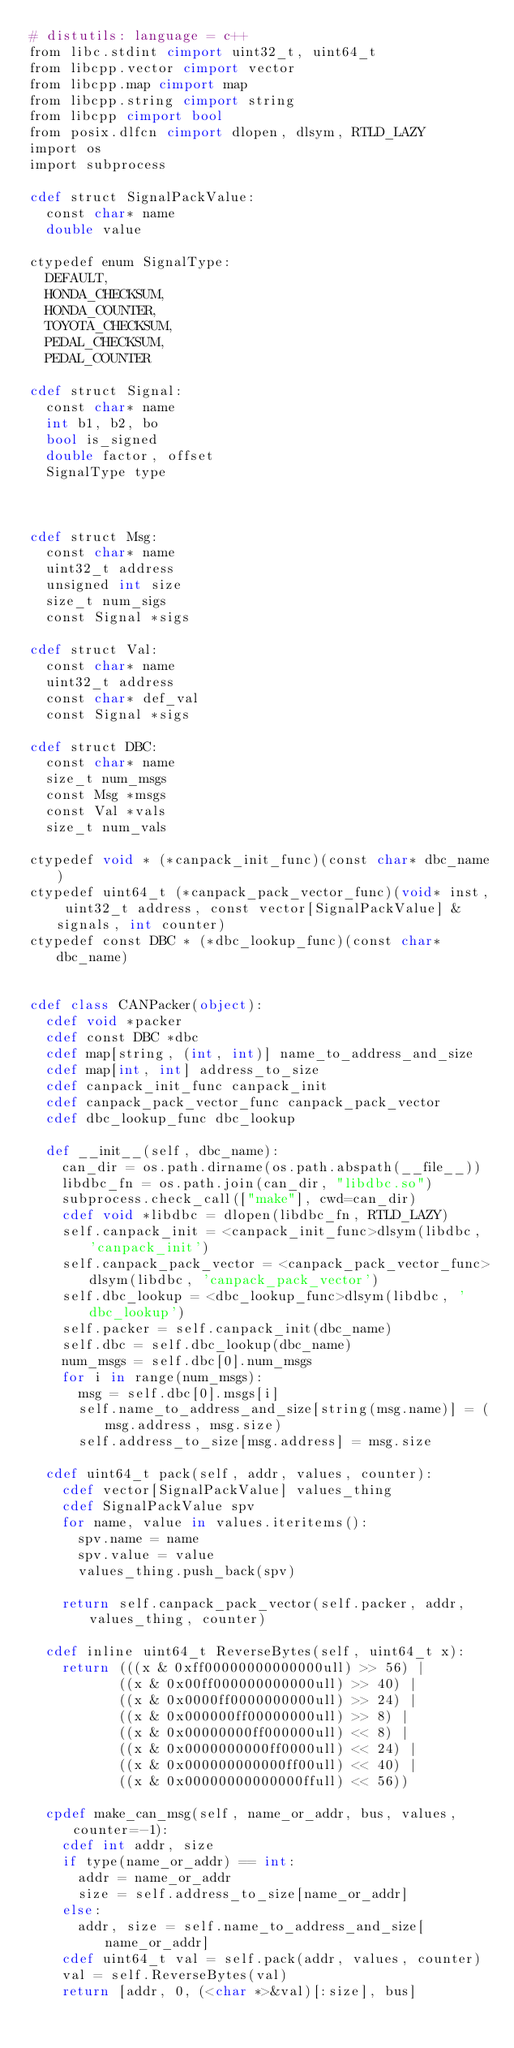<code> <loc_0><loc_0><loc_500><loc_500><_Cython_># distutils: language = c++
from libc.stdint cimport uint32_t, uint64_t
from libcpp.vector cimport vector
from libcpp.map cimport map
from libcpp.string cimport string
from libcpp cimport bool
from posix.dlfcn cimport dlopen, dlsym, RTLD_LAZY
import os
import subprocess

cdef struct SignalPackValue:
  const char* name
  double value

ctypedef enum SignalType:
  DEFAULT,
  HONDA_CHECKSUM,
  HONDA_COUNTER,
  TOYOTA_CHECKSUM,
  PEDAL_CHECKSUM,
  PEDAL_COUNTER

cdef struct Signal:
  const char* name
  int b1, b2, bo
  bool is_signed
  double factor, offset
  SignalType type



cdef struct Msg:
  const char* name
  uint32_t address
  unsigned int size
  size_t num_sigs
  const Signal *sigs

cdef struct Val:
  const char* name
  uint32_t address
  const char* def_val
  const Signal *sigs

cdef struct DBC:
  const char* name
  size_t num_msgs
  const Msg *msgs
  const Val *vals
  size_t num_vals

ctypedef void * (*canpack_init_func)(const char* dbc_name)
ctypedef uint64_t (*canpack_pack_vector_func)(void* inst, uint32_t address, const vector[SignalPackValue] &signals, int counter)
ctypedef const DBC * (*dbc_lookup_func)(const char* dbc_name)


cdef class CANPacker(object):
  cdef void *packer
  cdef const DBC *dbc
  cdef map[string, (int, int)] name_to_address_and_size
  cdef map[int, int] address_to_size
  cdef canpack_init_func canpack_init
  cdef canpack_pack_vector_func canpack_pack_vector
  cdef dbc_lookup_func dbc_lookup

  def __init__(self, dbc_name):
    can_dir = os.path.dirname(os.path.abspath(__file__))
    libdbc_fn = os.path.join(can_dir, "libdbc.so")
    subprocess.check_call(["make"], cwd=can_dir)
    cdef void *libdbc = dlopen(libdbc_fn, RTLD_LAZY)
    self.canpack_init = <canpack_init_func>dlsym(libdbc, 'canpack_init')
    self.canpack_pack_vector = <canpack_pack_vector_func>dlsym(libdbc, 'canpack_pack_vector')
    self.dbc_lookup = <dbc_lookup_func>dlsym(libdbc, 'dbc_lookup')
    self.packer = self.canpack_init(dbc_name)
    self.dbc = self.dbc_lookup(dbc_name)
    num_msgs = self.dbc[0].num_msgs
    for i in range(num_msgs):
      msg = self.dbc[0].msgs[i]
      self.name_to_address_and_size[string(msg.name)] = (msg.address, msg.size)
      self.address_to_size[msg.address] = msg.size

  cdef uint64_t pack(self, addr, values, counter):
    cdef vector[SignalPackValue] values_thing
    cdef SignalPackValue spv
    for name, value in values.iteritems():
      spv.name = name
      spv.value = value
      values_thing.push_back(spv)

    return self.canpack_pack_vector(self.packer, addr, values_thing, counter)

  cdef inline uint64_t ReverseBytes(self, uint64_t x):
    return (((x & 0xff00000000000000ull) >> 56) |
           ((x & 0x00ff000000000000ull) >> 40) |
           ((x & 0x0000ff0000000000ull) >> 24) |
           ((x & 0x000000ff00000000ull) >> 8) |
           ((x & 0x00000000ff000000ull) << 8) |
           ((x & 0x0000000000ff0000ull) << 24) |
           ((x & 0x000000000000ff00ull) << 40) |
           ((x & 0x00000000000000ffull) << 56))

  cpdef make_can_msg(self, name_or_addr, bus, values, counter=-1):
    cdef int addr, size
    if type(name_or_addr) == int:
      addr = name_or_addr
      size = self.address_to_size[name_or_addr]
    else:
      addr, size = self.name_to_address_and_size[name_or_addr]
    cdef uint64_t val = self.pack(addr, values, counter)
    val = self.ReverseBytes(val)
    return [addr, 0, (<char *>&val)[:size], bus]
</code> 